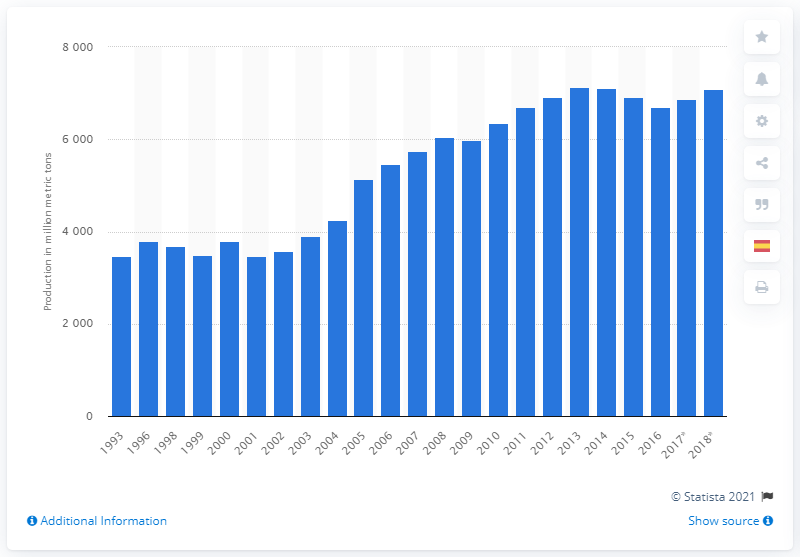Indicate a few pertinent items in this graphic. In 2007, a total of 57,35.78 metric tons of hard coal was produced globally. In 2018, a total of 57,35.78 metric tons of hard coal were produced globally. 